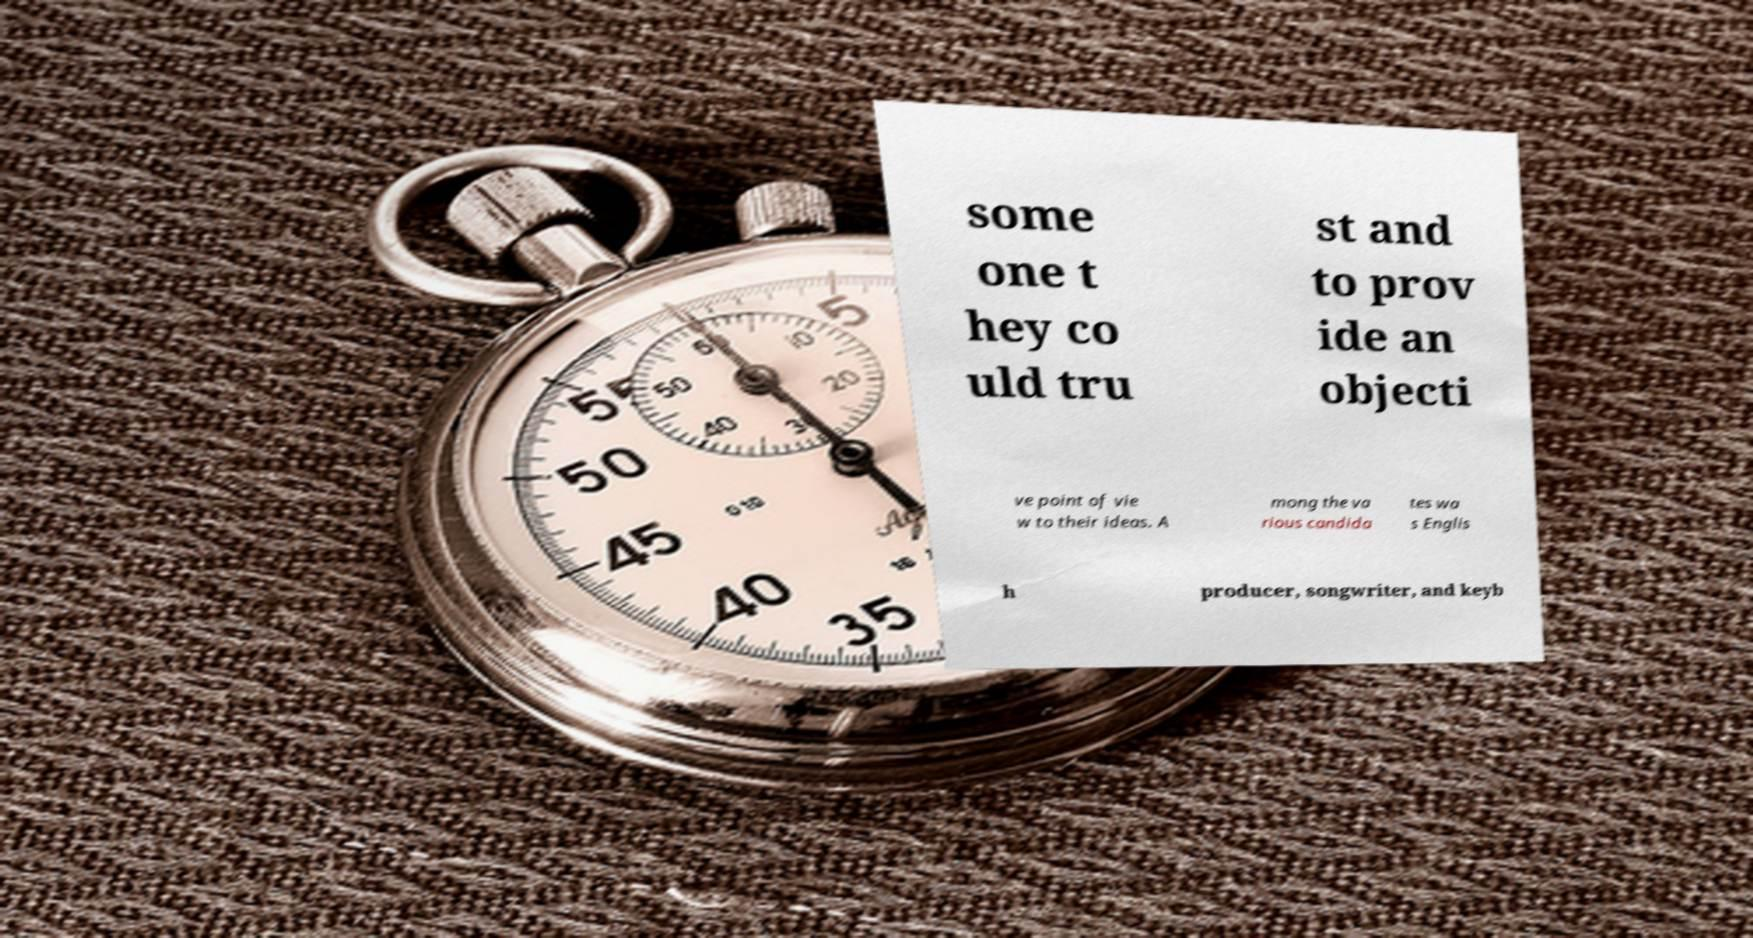Please read and relay the text visible in this image. What does it say? some one t hey co uld tru st and to prov ide an objecti ve point of vie w to their ideas. A mong the va rious candida tes wa s Englis h producer, songwriter, and keyb 